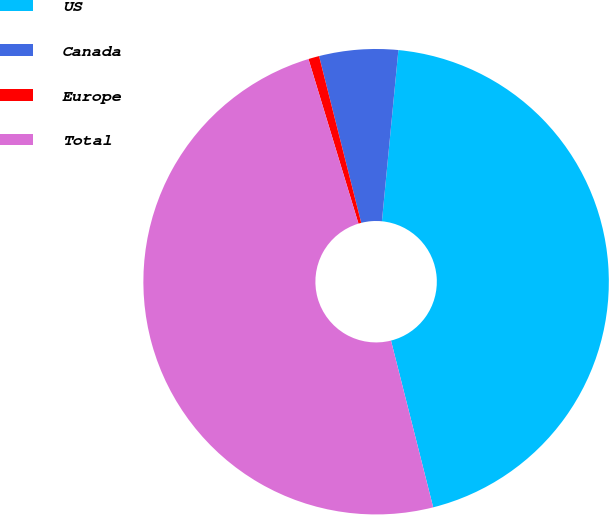Convert chart. <chart><loc_0><loc_0><loc_500><loc_500><pie_chart><fcel>US<fcel>Canada<fcel>Europe<fcel>Total<nl><fcel>44.53%<fcel>5.47%<fcel>0.75%<fcel>49.25%<nl></chart> 